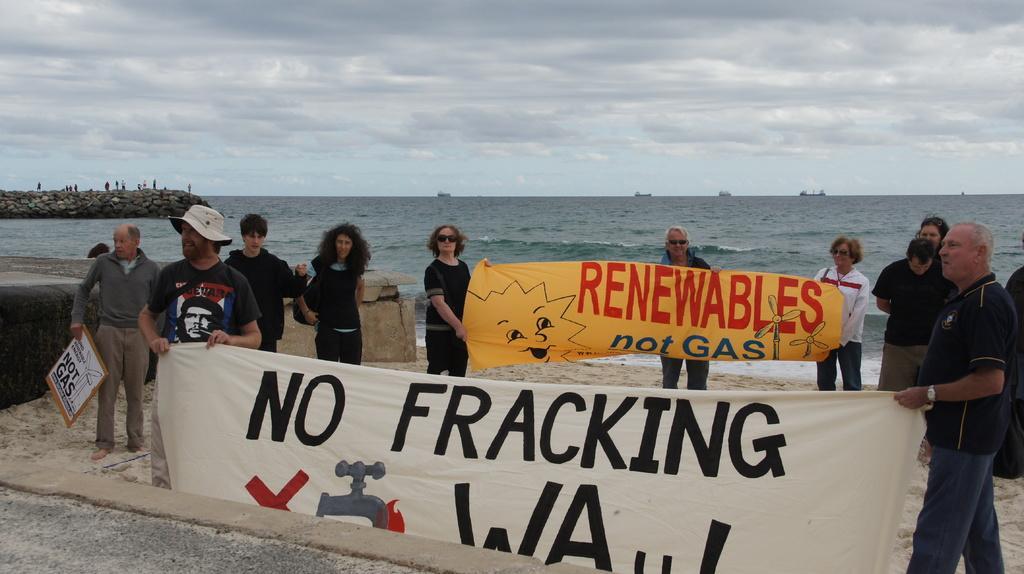How would you summarize this image in a sentence or two? In this image in the front there are persons standing and holding banner in their hands. In the center there are persons standing and there are persons holding banner with some text written on it. In the background there is an ocean and the sky is cloudy. 